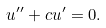Convert formula to latex. <formula><loc_0><loc_0><loc_500><loc_500>u ^ { \prime \prime } + c u ^ { \prime } = 0 .</formula> 